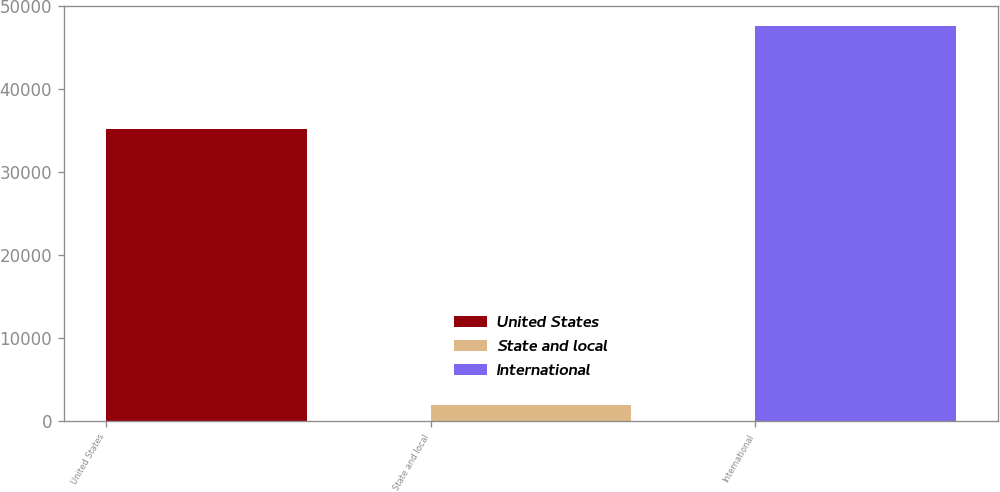<chart> <loc_0><loc_0><loc_500><loc_500><bar_chart><fcel>United States<fcel>State and local<fcel>International<nl><fcel>35232<fcel>1931<fcel>47633<nl></chart> 